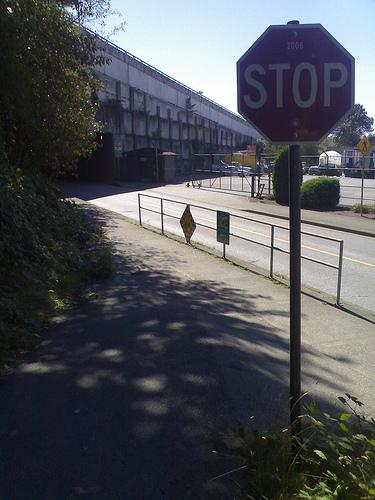Question: what is written on the red sign?
Choices:
A. Caution.
B. Yield.
C. Stop.
D. Detour.
Answer with the letter. Answer: C Question: where are the shadows?
Choices:
A. Wall.
B. Lawn.
C. Sidewalk.
D. Patio.
Answer with the letter. Answer: C Question: why is the railing there?
Choices:
A. Decoration.
B. Safety.
C. Boundary.
D. Caution.
Answer with the letter. Answer: B Question: what color are the stripes on the road?
Choices:
A. Green.
B. Yellow.
C. White.
D. Blue.
Answer with the letter. Answer: B Question: what is the yellow sign for on the fence?
Choices:
A. Caution.
B. Detour.
C. Zoning.
D. Pedestrian crossing.
Answer with the letter. Answer: D 